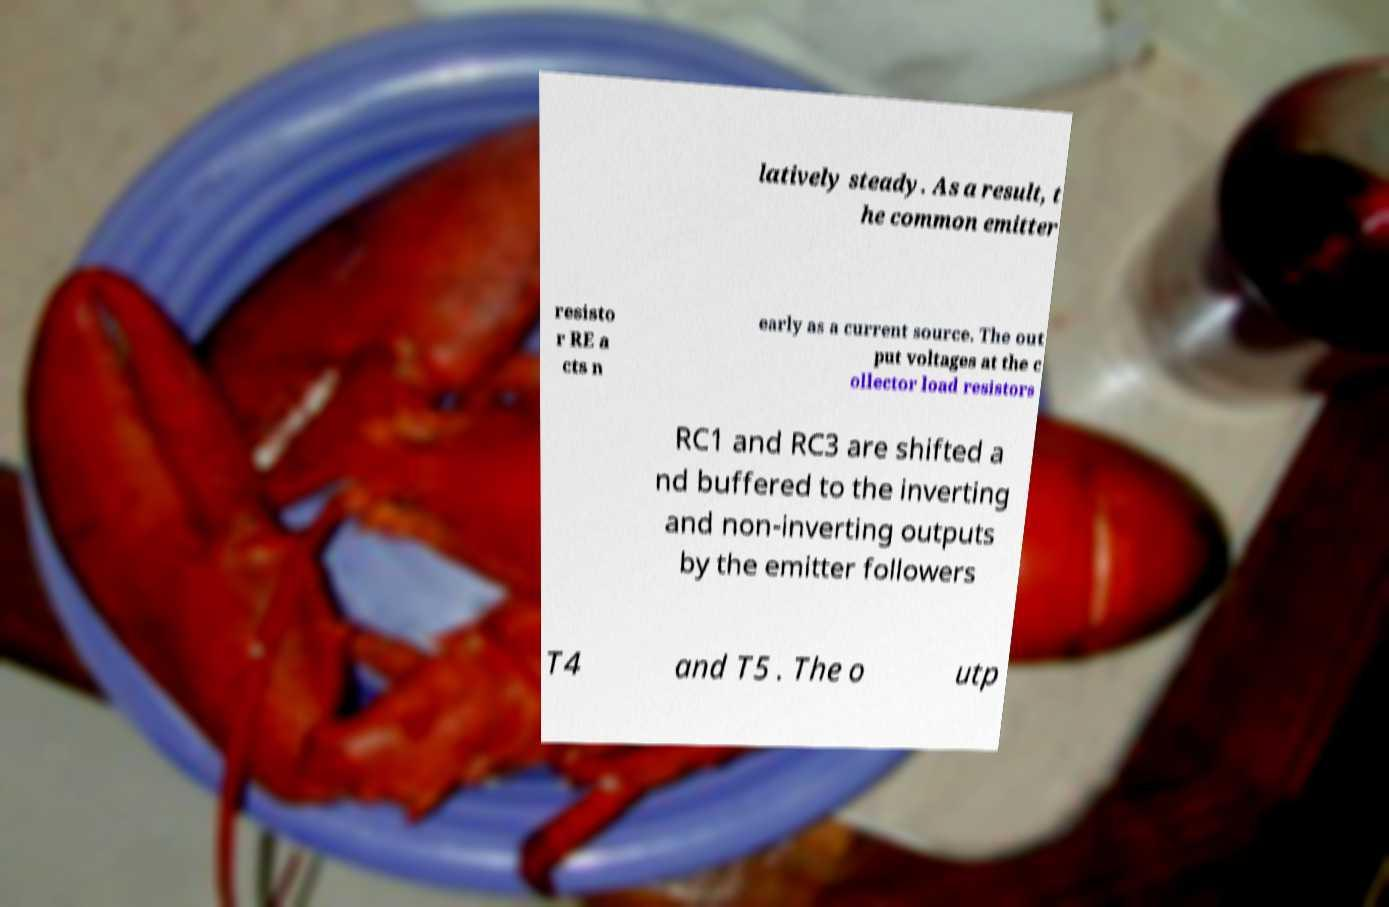For documentation purposes, I need the text within this image transcribed. Could you provide that? latively steady. As a result, t he common emitter resisto r RE a cts n early as a current source. The out put voltages at the c ollector load resistors RC1 and RC3 are shifted a nd buffered to the inverting and non-inverting outputs by the emitter followers T4 and T5 . The o utp 